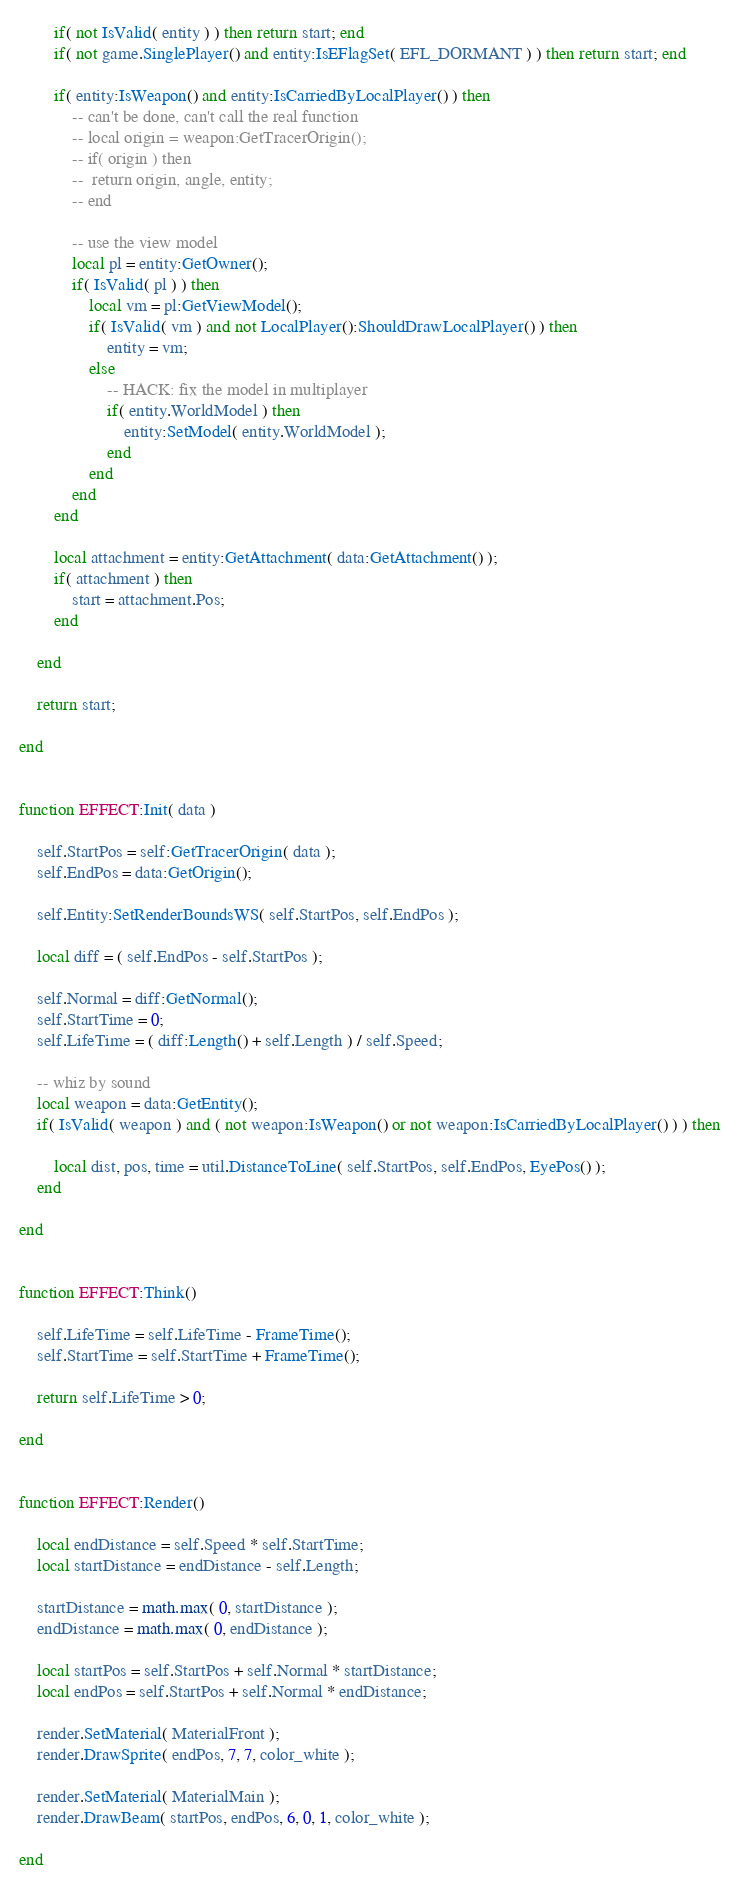Convert code to text. <code><loc_0><loc_0><loc_500><loc_500><_Lua_>		if( not IsValid( entity ) ) then return start; end
		if( not game.SinglePlayer() and entity:IsEFlagSet( EFL_DORMANT ) ) then return start; end
		
		if( entity:IsWeapon() and entity:IsCarriedByLocalPlayer() ) then
			-- can't be done, can't call the real function
			-- local origin = weapon:GetTracerOrigin();
			-- if( origin ) then
			-- 	return origin, angle, entity;
			-- end
			
			-- use the view model
			local pl = entity:GetOwner();
			if( IsValid( pl ) ) then
				local vm = pl:GetViewModel();
				if( IsValid( vm ) and not LocalPlayer():ShouldDrawLocalPlayer() ) then
					entity = vm;
				else
					-- HACK: fix the model in multiplayer
					if( entity.WorldModel ) then
						entity:SetModel( entity.WorldModel );
					end
				end
			end
		end

		local attachment = entity:GetAttachment( data:GetAttachment() );
		if( attachment ) then
			start = attachment.Pos;
		end

	end
	
	return start;

end


function EFFECT:Init( data )

	self.StartPos = self:GetTracerOrigin( data );
	self.EndPos = data:GetOrigin();
	
	self.Entity:SetRenderBoundsWS( self.StartPos, self.EndPos );

	local diff = ( self.EndPos - self.StartPos );
	
	self.Normal = diff:GetNormal();
	self.StartTime = 0;
	self.LifeTime = ( diff:Length() + self.Length ) / self.Speed;
	
	-- whiz by sound
	local weapon = data:GetEntity();
	if( IsValid( weapon ) and ( not weapon:IsWeapon() or not weapon:IsCarriedByLocalPlayer() ) ) then

		local dist, pos, time = util.DistanceToLine( self.StartPos, self.EndPos, EyePos() );
	end

end


function EFFECT:Think()

	self.LifeTime = self.LifeTime - FrameTime();
	self.StartTime = self.StartTime + FrameTime(); 

	return self.LifeTime > 0;

end


function EFFECT:Render()

	local endDistance = self.Speed * self.StartTime;
	local startDistance = endDistance - self.Length;
	
	startDistance = math.max( 0, startDistance );
	endDistance = math.max( 0, endDistance );

	local startPos = self.StartPos + self.Normal * startDistance;
	local endPos = self.StartPos + self.Normal * endDistance;
	
	render.SetMaterial( MaterialFront );
	render.DrawSprite( endPos, 7, 7, color_white );

	render.SetMaterial( MaterialMain );
	render.DrawBeam( startPos, endPos, 6, 0, 1, color_white );
	
end
</code> 